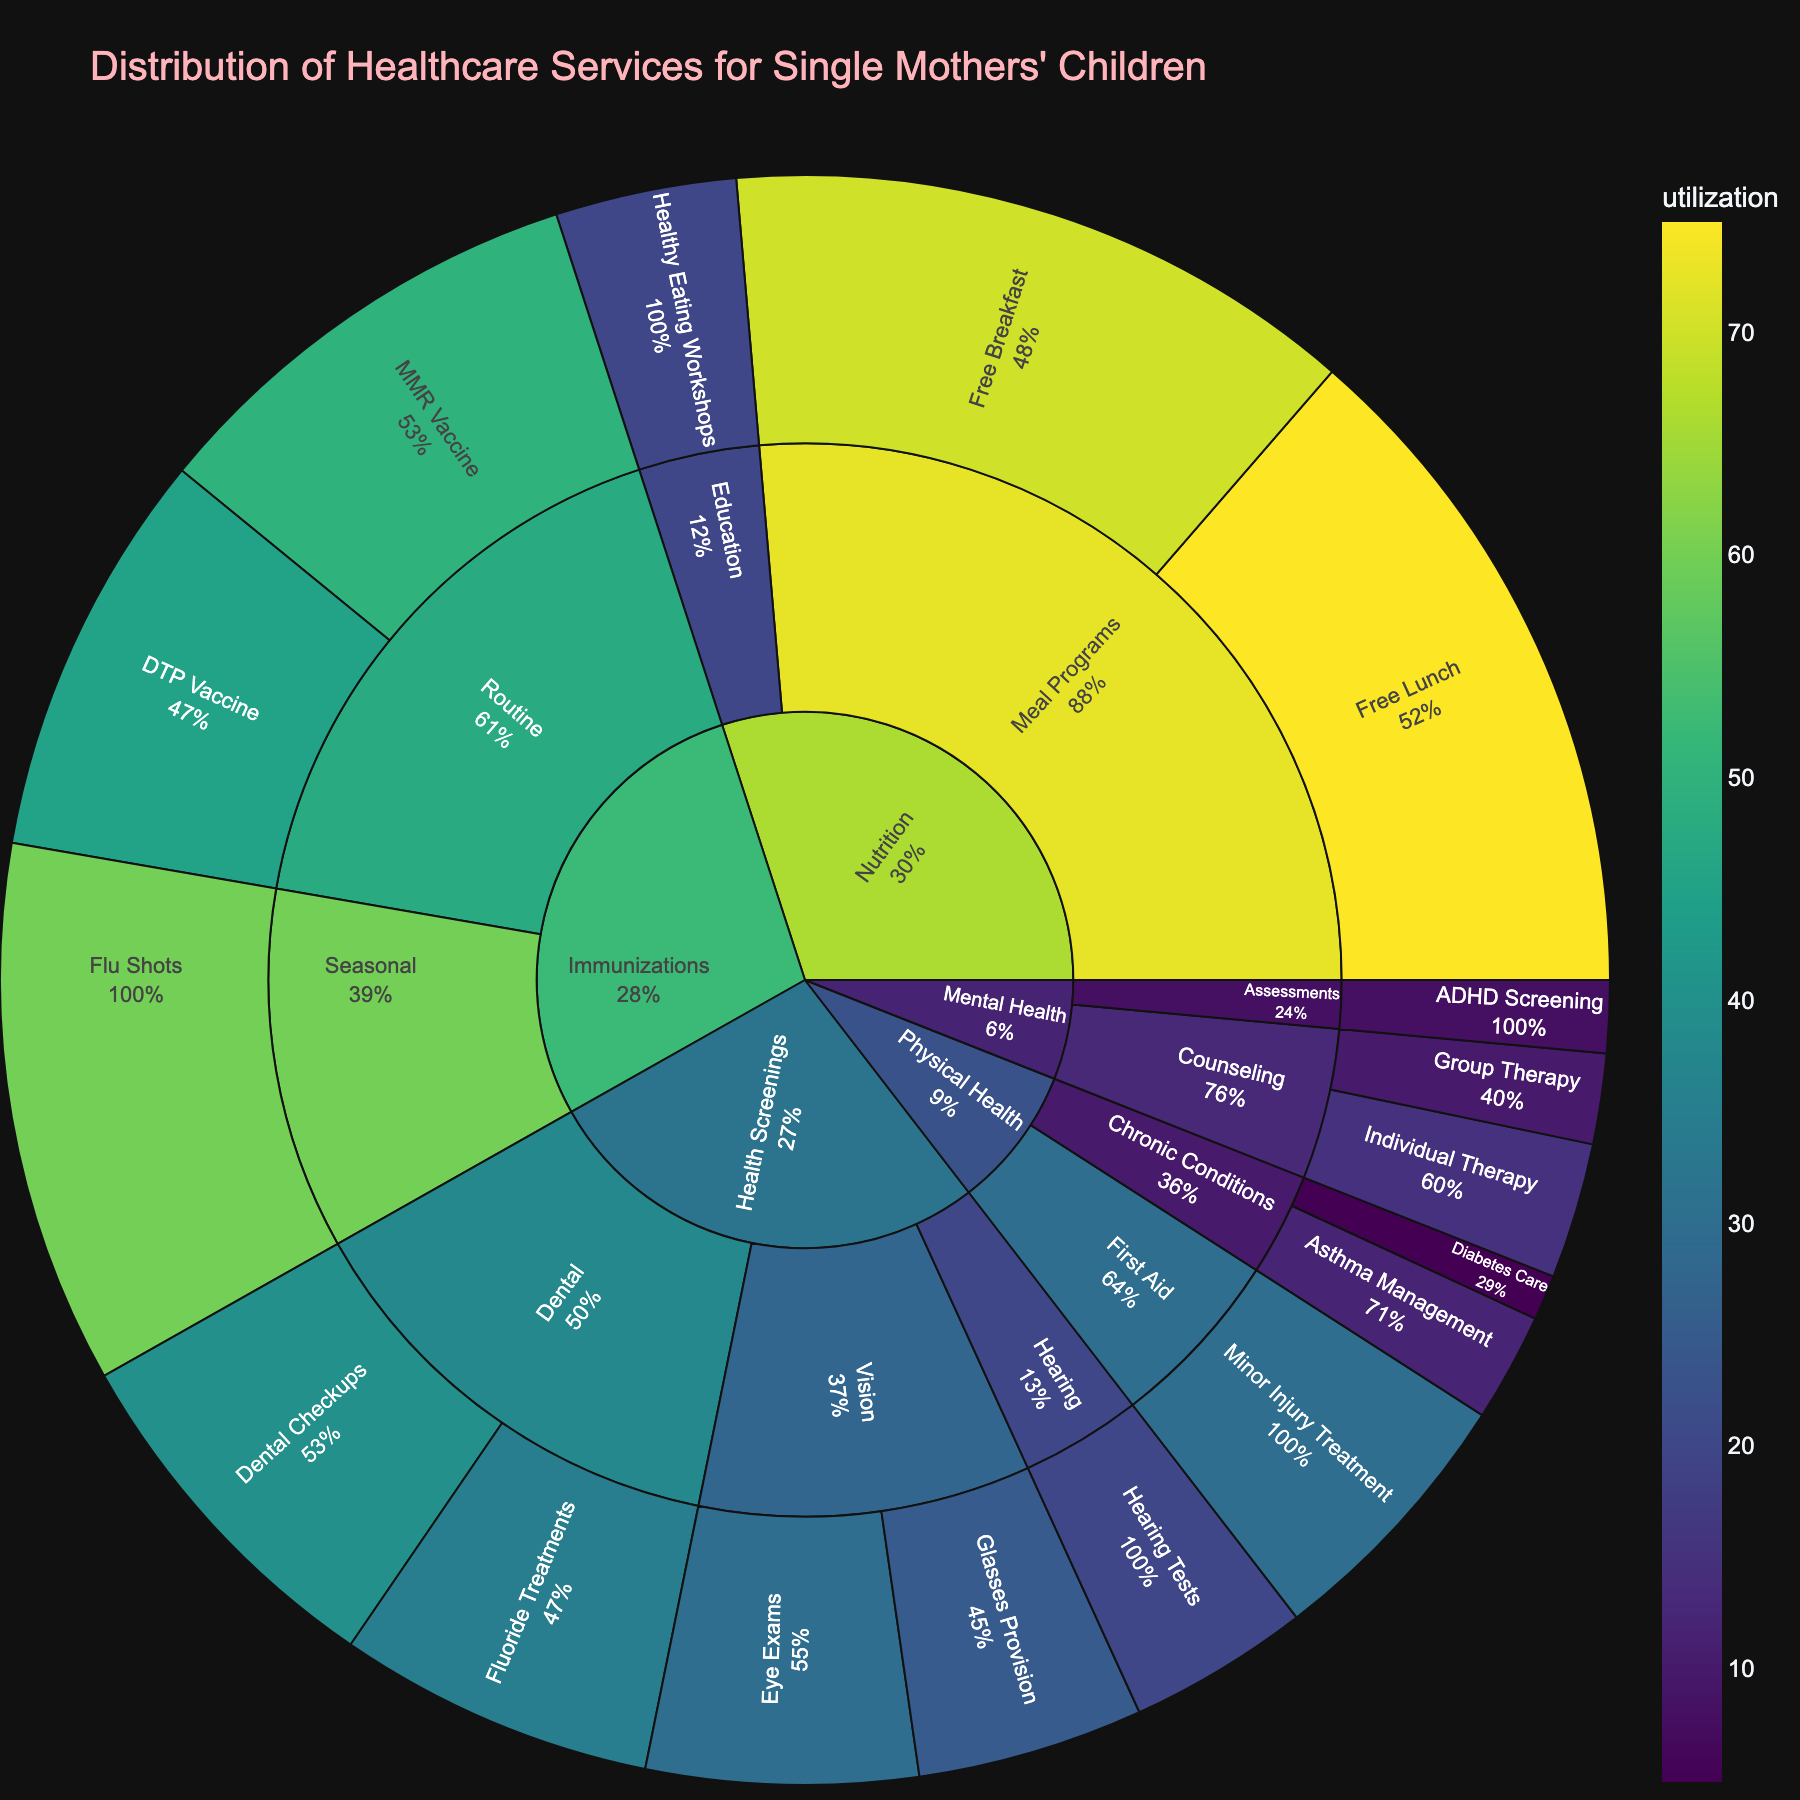How many total healthcare services are categorized under Health Screenings? To find the total number of healthcare services under Health Screenings, add up the utilization values for Vision, Dental, and Hearing screenings. The specific values are Eye Exams (30), Glasses Provision (25), Dental Checkups (40), Fluoride Treatments (35), and Hearing Tests (20). Sum these up: 30 + 25 + 40 + 35 + 20 = 150.
Answer: 150 Which service has the highest utilization among Immunizations? Look at the segment for Immunizations and compare the utilization values for Routine (MMR Vaccine, DTP Vaccine) and Seasonal (Flu Shots). The Flu Shots segment shows the highest utilization at 60.
Answer: Flu Shots What is the combined utilization for all services under Nutrition? Add up the utilization values for Free Breakfast (70), Free Lunch (75), and Healthy Eating Workshops (20). Summing these values: 70 + 75 + 20 = 165.
Answer: 165 Compare the utilization between Individual Therapy and Group Therapy within Mental Health – Counseling. Which is higher and by how much? By looking at the Mental Health – Counseling segment, Individual Therapy has a utilization value of 15, and Group Therapy has 10. The difference is 15 - 10 = 5. Individual Therapy utilization is higher by 5.
Answer: Individual Therapy by 5 By how much does the utilization of Routine Immunizations exceed that of Chronic Conditions in Physical Health? Calculate the total utilization for Routine Immunizations (MMR Vaccine: 50 + DTP Vaccine: 45 = 95) and Chronic Conditions in Physical Health (Asthma Management: 12 + Diabetes Care: 5 = 17). Subtract to find the difference: 95 - 17 = 78.
Answer: 78 Which subcategory under Health Screenings has the lowest utilization, and what is the value? In Health Screenings, compare Vision (Eye Exams, Glasses Provision), Dental (Dental Checkups, Fluoride Treatments), and Hearing (Hearing Tests). Hearing has the lowest utilization with a value of 20 from Hearing Tests.
Answer: Hearing, 20 What percentage of the total Nutrition services utilization is taken up by Free Lunch? Calculate the total utilization for Nutrition (70 + 75 + 20 = 165). Free Lunch has a utilization value of 75. To find the percentage: (75 / 165) * 100 = approximately 45.45%.
Answer: Approximately 45.45% How does the utilization of Health Screenings - Dental compare with that of Routine - Immunizations? Sum up the utilization for Health Screenings - Dental (Dental Checkups: 40 + Fluoride Treatments: 35 = 75) and compare with Routine - Immunizations (MMR Vaccine: 50 + DTP Vaccine: 45 = 95). The Routine Immunizations have higher utilization by 95 - 75 = 20.
Answer: Routine Immunizations by 20 Which healthcare category has the highest overall utilization? Compare the total values of all categories: Health Screenings (30 + 25 + 40 + 35 + 20 = 150), Immunizations (50 + 45 + 60 = 155), Mental Health (15 + 10 + 8 = 33), Nutrition (70 + 75 + 20 = 165), Physical Health (12 + 5 + 30 = 47). Nutrition has the highest overall utilization with 165.
Answer: Nutrition What is the total utilization for all services under Physical Health? Add up the values for Asthma Management (12), Diabetes Care (5), and Minor Injury Treatment (30). Total utilization is 12 + 5 + 30 = 47.
Answer: 47 